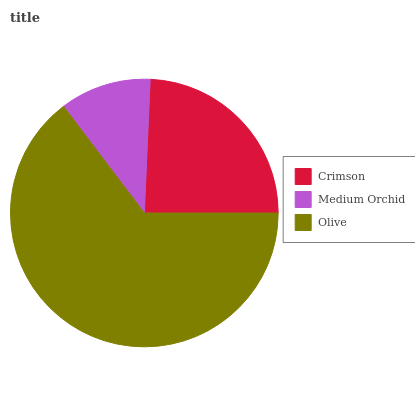Is Medium Orchid the minimum?
Answer yes or no. Yes. Is Olive the maximum?
Answer yes or no. Yes. Is Olive the minimum?
Answer yes or no. No. Is Medium Orchid the maximum?
Answer yes or no. No. Is Olive greater than Medium Orchid?
Answer yes or no. Yes. Is Medium Orchid less than Olive?
Answer yes or no. Yes. Is Medium Orchid greater than Olive?
Answer yes or no. No. Is Olive less than Medium Orchid?
Answer yes or no. No. Is Crimson the high median?
Answer yes or no. Yes. Is Crimson the low median?
Answer yes or no. Yes. Is Olive the high median?
Answer yes or no. No. Is Medium Orchid the low median?
Answer yes or no. No. 